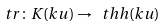Convert formula to latex. <formula><loc_0><loc_0><loc_500><loc_500>t r \colon K ( k u ) \to \ t h h ( k u )</formula> 